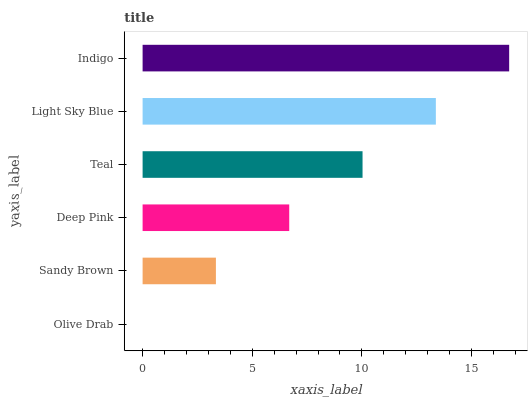Is Olive Drab the minimum?
Answer yes or no. Yes. Is Indigo the maximum?
Answer yes or no. Yes. Is Sandy Brown the minimum?
Answer yes or no. No. Is Sandy Brown the maximum?
Answer yes or no. No. Is Sandy Brown greater than Olive Drab?
Answer yes or no. Yes. Is Olive Drab less than Sandy Brown?
Answer yes or no. Yes. Is Olive Drab greater than Sandy Brown?
Answer yes or no. No. Is Sandy Brown less than Olive Drab?
Answer yes or no. No. Is Teal the high median?
Answer yes or no. Yes. Is Deep Pink the low median?
Answer yes or no. Yes. Is Olive Drab the high median?
Answer yes or no. No. Is Teal the low median?
Answer yes or no. No. 